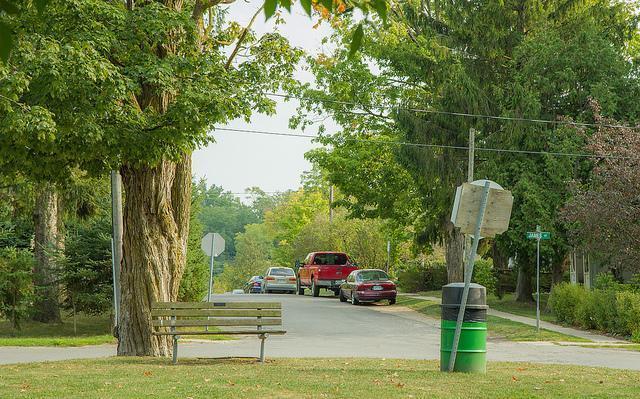How many people are facing the camera?
Give a very brief answer. 0. 